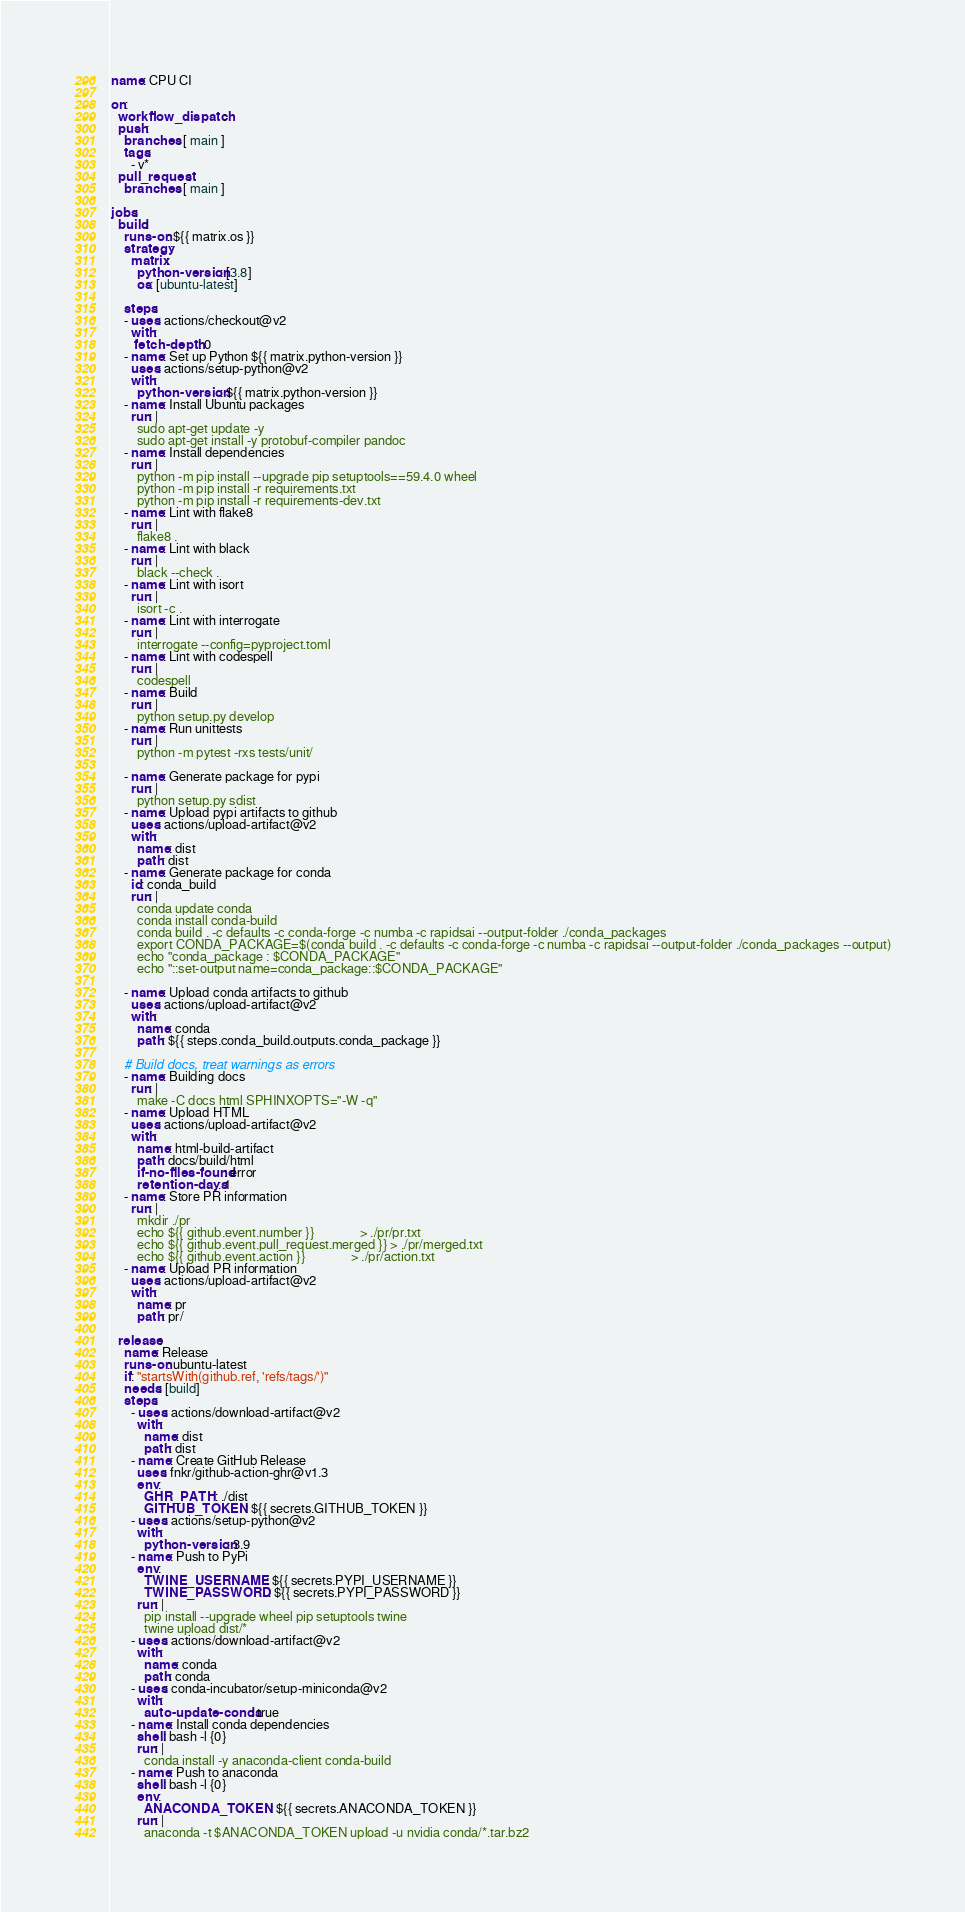Convert code to text. <code><loc_0><loc_0><loc_500><loc_500><_YAML_>name: CPU CI

on:
  workflow_dispatch:
  push:
    branches: [ main ]
    tags:
      - v*
  pull_request:
    branches: [ main ]

jobs:
  build:
    runs-on: ${{ matrix.os }}
    strategy:
      matrix:
        python-version: [3.8]
        os: [ubuntu-latest]

    steps:
    - uses: actions/checkout@v2
      with:
       fetch-depth: 0
    - name: Set up Python ${{ matrix.python-version }}
      uses: actions/setup-python@v2
      with:
        python-version: ${{ matrix.python-version }}
    - name: Install Ubuntu packages
      run: |
        sudo apt-get update -y
        sudo apt-get install -y protobuf-compiler pandoc
    - name: Install dependencies
      run: |
        python -m pip install --upgrade pip setuptools==59.4.0 wheel 
        python -m pip install -r requirements.txt
        python -m pip install -r requirements-dev.txt
    - name: Lint with flake8
      run: |
        flake8 .
    - name: Lint with black
      run: |
        black --check .
    - name: Lint with isort
      run: |
        isort -c .
    - name: Lint with interrogate
      run: |
        interrogate --config=pyproject.toml
    - name: Lint with codespell
      run: |
        codespell
    - name: Build
      run: |
        python setup.py develop
    - name: Run unittests
      run: |
        python -m pytest -rxs tests/unit/

    - name: Generate package for pypi
      run: |
        python setup.py sdist
    - name: Upload pypi artifacts to github
      uses: actions/upload-artifact@v2
      with:
        name: dist
        path: dist
    - name: Generate package for conda
      id: conda_build
      run: |
        conda update conda
        conda install conda-build
        conda build . -c defaults -c conda-forge -c numba -c rapidsai --output-folder ./conda_packages
        export CONDA_PACKAGE=$(conda build . -c defaults -c conda-forge -c numba -c rapidsai --output-folder ./conda_packages --output)
        echo "conda_package : $CONDA_PACKAGE"
        echo "::set-output name=conda_package::$CONDA_PACKAGE"

    - name: Upload conda artifacts to github
      uses: actions/upload-artifact@v2
      with:
        name: conda
        path: ${{ steps.conda_build.outputs.conda_package }}

    # Build docs, treat warnings as errors
    - name: Building docs
      run: |
        make -C docs html SPHINXOPTS="-W -q"
    - name: Upload HTML
      uses: actions/upload-artifact@v2
      with:
        name: html-build-artifact
        path: docs/build/html
        if-no-files-found: error
        retention-days: 1
    - name: Store PR information
      run: |
        mkdir ./pr
        echo ${{ github.event.number }}              > ./pr/pr.txt
        echo ${{ github.event.pull_request.merged }} > ./pr/merged.txt
        echo ${{ github.event.action }}              > ./pr/action.txt
    - name: Upload PR information
      uses: actions/upload-artifact@v2
      with:
        name: pr
        path: pr/

  release:
    name: Release
    runs-on: ubuntu-latest
    if: "startsWith(github.ref, 'refs/tags/')"
    needs: [build]
    steps:
      - uses: actions/download-artifact@v2
        with:
          name: dist
          path: dist
      - name: Create GitHub Release
        uses: fnkr/github-action-ghr@v1.3
        env:
          GHR_PATH: ./dist
          GITHUB_TOKEN: ${{ secrets.GITHUB_TOKEN }}
      - uses: actions/setup-python@v2
        with:
          python-version: 3.9
      - name: Push to PyPi
        env:
          TWINE_USERNAME: ${{ secrets.PYPI_USERNAME }}
          TWINE_PASSWORD: ${{ secrets.PYPI_PASSWORD }}
        run: |
          pip install --upgrade wheel pip setuptools twine
          twine upload dist/*
      - uses: actions/download-artifact@v2
        with:
          name: conda
          path: conda
      - uses: conda-incubator/setup-miniconda@v2
        with:
          auto-update-conda: true
      - name: Install conda dependencies
        shell: bash -l {0}
        run: |
          conda install -y anaconda-client conda-build
      - name: Push to anaconda
        shell: bash -l {0}
        env:
          ANACONDA_TOKEN: ${{ secrets.ANACONDA_TOKEN }}
        run: |
          anaconda -t $ANACONDA_TOKEN upload -u nvidia conda/*.tar.bz2
</code> 